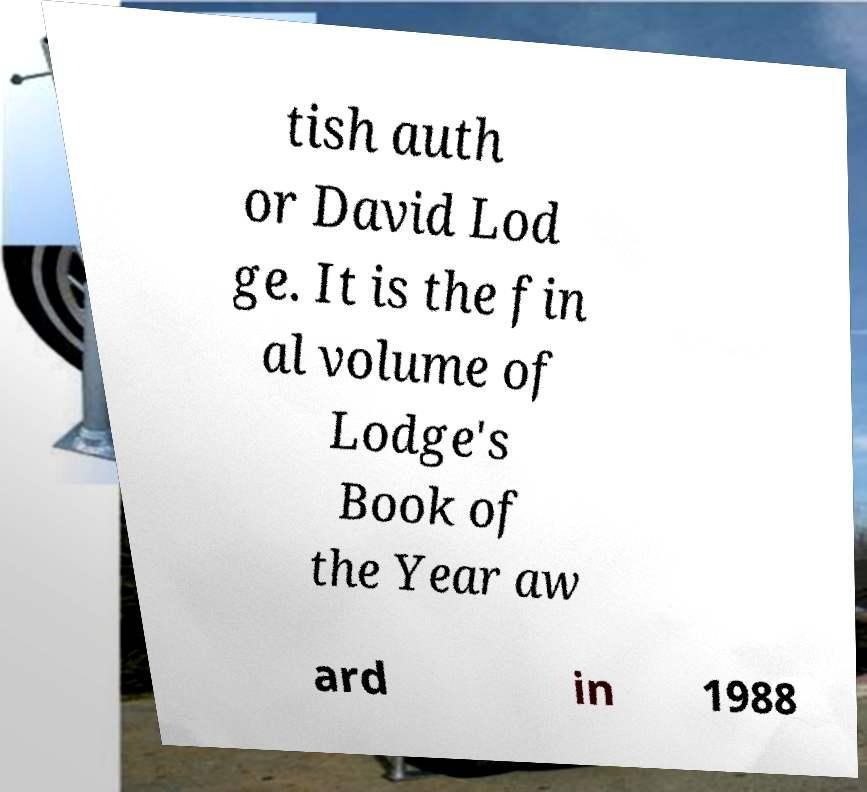Can you accurately transcribe the text from the provided image for me? tish auth or David Lod ge. It is the fin al volume of Lodge's Book of the Year aw ard in 1988 